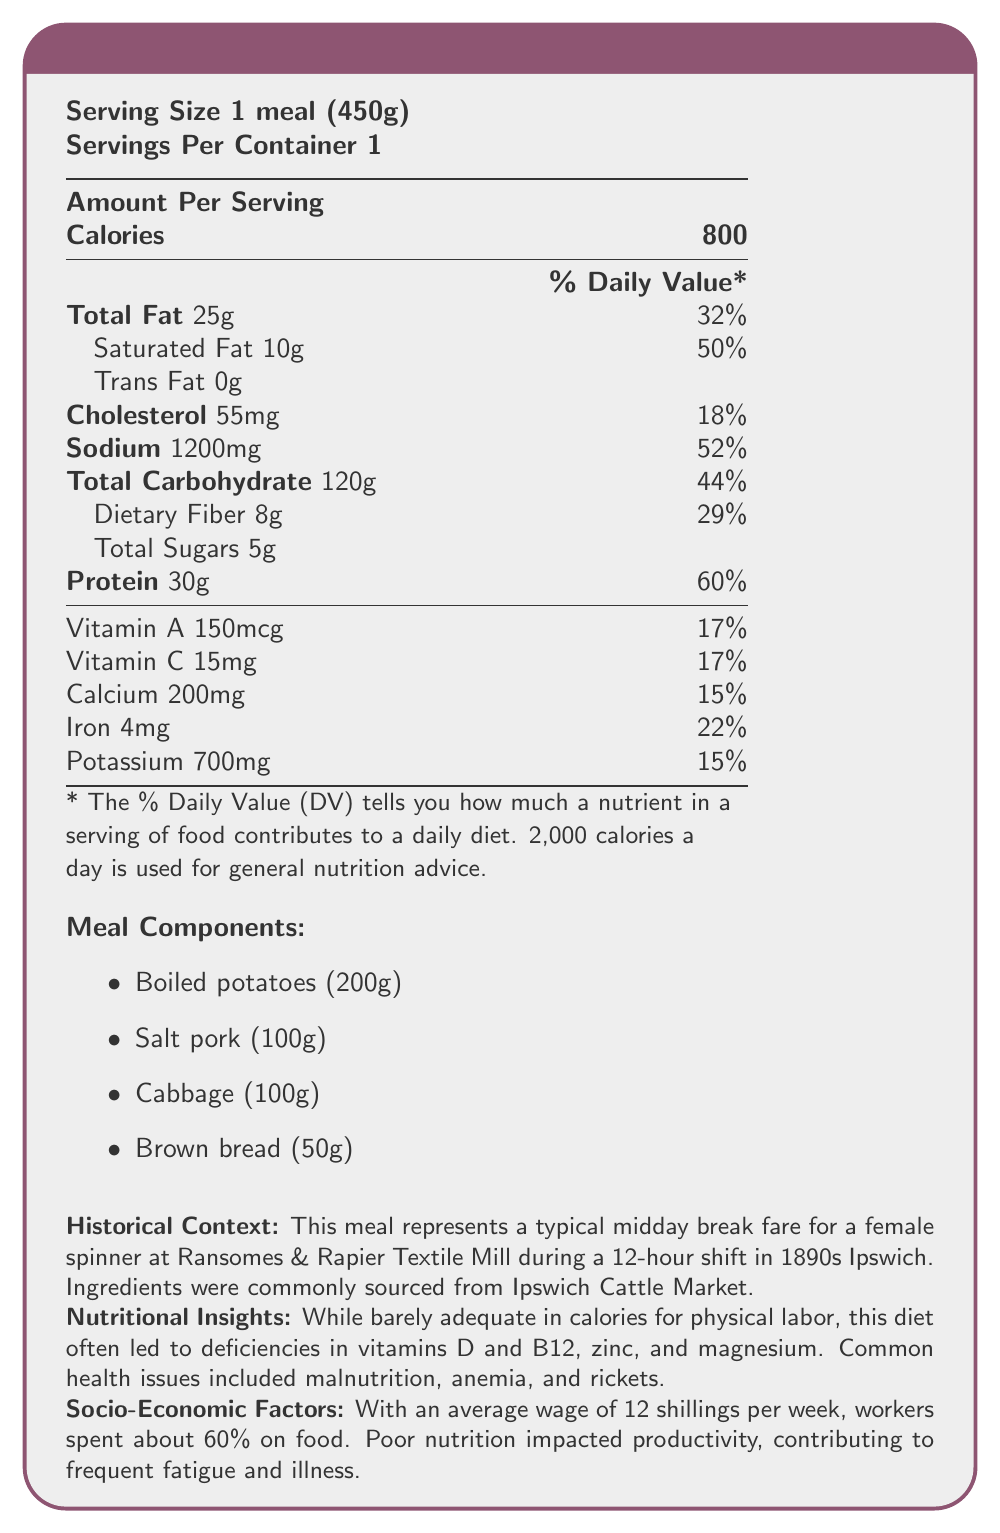who was the typical worker described in the historical context? The document mentions the typical worker as a female spinner in the Ransomes & Rapier Textile Mill during the 1890s Ipswich.
Answer: Female spinner how many grams of potatoes are included in the meal? The meal components list shows that the meal includes 200 grams of boiled potatoes.
Answer: 200g what is the daily value percentage of sodium in the meal? The nutrition facts section lists sodium content as 1200mg, which is 52% of the daily value.
Answer: 52% how many grams of total carbohydrate does the meal provide? The nutrition facts section lists the total carbohydrate content as 120 grams.
Answer: 120g what are the common health issues mentioned in the historical context? The historical context mentions malnutrition, anemia, and rickets as common health issues.
Answer: Malnutrition, Anemia, Rickets which of the following components is not included in the meal? A. Cabbage B. Brown bread C. Fish D. Boiled potatoes The meal components list includes cabbage, brown bread, and boiled potatoes but not fish.
Answer: C. Fish what is the key protein source in the meal as per the nutritional insights? A. Cabbage B. Boiled potatoes C. Salt pork D. Brown bread The nutritional insights section mentions that protein is primarily sourced from salt pork.
Answer: C. Salt pork does the meal contain any trans fat? The nutrition facts section shows that the trans fat content is 0 grams.
Answer: No what are the typical working hours described for the workers? The historical context mentions that the workers typically had a 12-hour shift.
Answer: 12-hour shift what is the primary source of food ingredients for the meal? The historical context notes that ingredients were commonly sourced from Ipswich Cattle Market.
Answer: Ipswich Cattle Market summarize the nutritional insights section. The nutritional insights section provides a detailed analysis of the meal's shortcomings, highlighting its inadequacy in meeting the nutritional needs of physical laborers and the resultant health issues.
Answer: The meal is barely adequate in calories for physical labor and primarily provides protein from salt pork. It leads to deficiencies in vitamins D and B12, as well as zinc and magnesium. Common health issues due to the meal include malnutrition, anemia, and rickets. which vitamins have a daily value percentage of 17% in this meal? The nutrition facts section lists Vitamin A as 150mcg (17% DV) and Vitamin C as 15mg (17% DV).
Answer: Vitamin A and Vitamin C what is the percentage of the weekly wage spent on food by workers? The socio-economic factors section mentions that workers spent about 60% of their weekly wage on food.
Answer: 60% was the calorie sufficiency adequate for the physical labor at the mill? The nutritional insights section mentions that the calorie sufficiency was barely adequate for the physical labor required at the mill.
Answer: Barely adequate what are the meal components listed in the document? The meal components section lists boiled potatoes, salt pork, cabbage, and brown bread with their respective amounts.
Answer: Boiled potatoes (200g), Salt pork (100g), Cabbage (100g), Brown bread (50g) what is the daily value percentage of calcium in the meal? The nutrition facts section lists calcium content as 200mg, which is 15% of the daily value.
Answer: 15% what are the nutritional deficiencies highlighted in the document? The nutritional insights section highlights deficiencies in vitamins D and B12, as well as zinc and magnesium.
Answer: Vitamin D, Vitamin B12, Zinc, Magnesium what was the impact of poor nutrition on productivity? The socio-economic factors section mentions that poor nutrition led to frequent fatigue and illness, impacting productivity.
Answer: Frequent fatigue and illness how much protein is provided in one serving of this meal? The nutrition facts section shows that the meal provides 30 grams of protein.
Answer: 30g what was the average wage of a worker in the late 19th century Ipswich textile mills? The socio-economic factors section mentions the average wage as 12 shillings per week.
Answer: 12 shillings per week can we determine the exact price of the meal components from the document? The document does not provide specific price information for each meal component.
Answer: Cannot be determined 